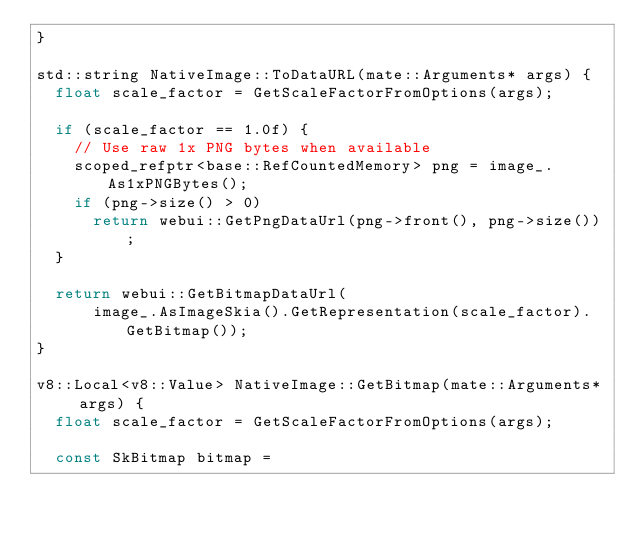<code> <loc_0><loc_0><loc_500><loc_500><_C++_>}

std::string NativeImage::ToDataURL(mate::Arguments* args) {
  float scale_factor = GetScaleFactorFromOptions(args);

  if (scale_factor == 1.0f) {
    // Use raw 1x PNG bytes when available
    scoped_refptr<base::RefCountedMemory> png = image_.As1xPNGBytes();
    if (png->size() > 0)
      return webui::GetPngDataUrl(png->front(), png->size());
  }

  return webui::GetBitmapDataUrl(
      image_.AsImageSkia().GetRepresentation(scale_factor).GetBitmap());
}

v8::Local<v8::Value> NativeImage::GetBitmap(mate::Arguments* args) {
  float scale_factor = GetScaleFactorFromOptions(args);

  const SkBitmap bitmap =</code> 